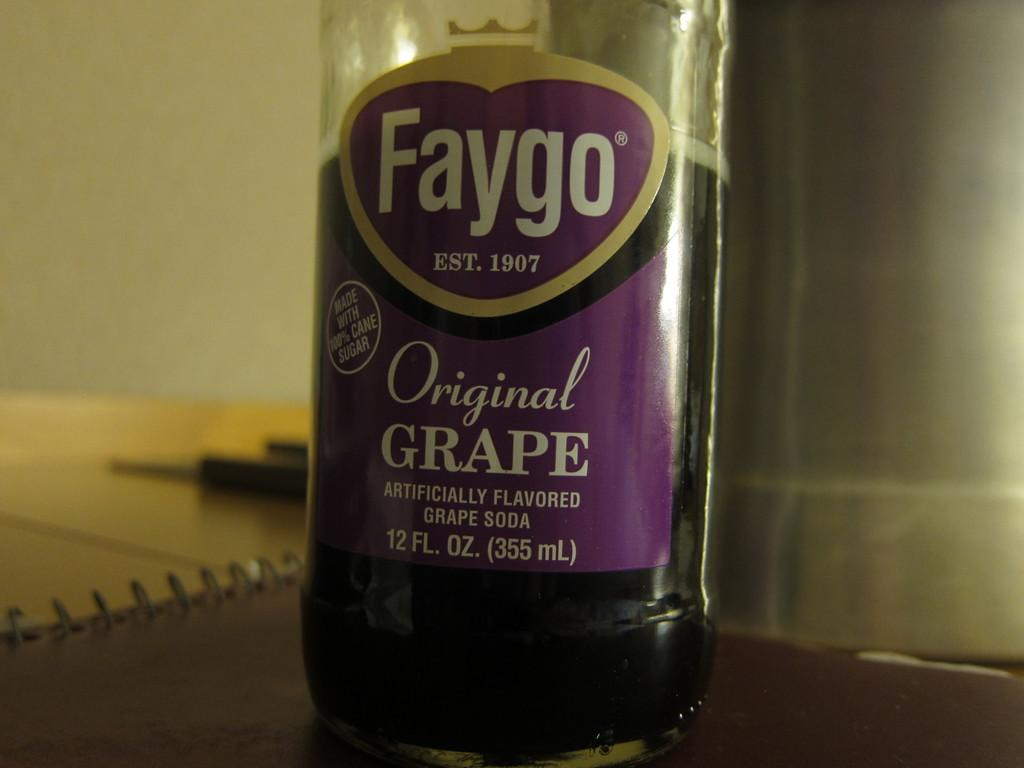<image>
Present a compact description of the photo's key features. A bottle of soda says Faygo Original Grape. 